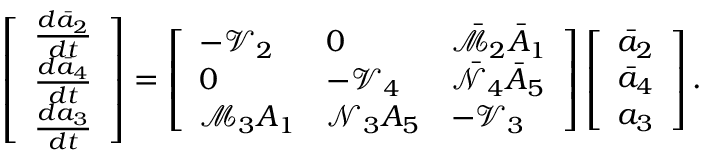Convert formula to latex. <formula><loc_0><loc_0><loc_500><loc_500>\left [ \begin{array} { l } { \frac { d \bar { a } _ { 2 } } { d t } } \\ { \frac { d \bar { a } _ { 4 } } { d t } } \\ { \frac { d { a } _ { 3 } } { d t } } \end{array} \right ] = \left [ \begin{array} { l l l } { - \mathcal { V } _ { 2 } } & { 0 } & { \bar { { \mathcal { M } } } _ { 2 } \bar { A } _ { 1 } } \\ { 0 } & { - \mathcal { V } _ { 4 } } & { \bar { \mathcal { N } } _ { 4 } \bar { A } _ { 5 } } \\ { { \mathcal { M } } _ { 3 } { A } _ { 1 } } & { { \mathcal { N } } _ { 3 } { A } _ { 5 } } & { - \mathcal { V } _ { 3 } } \end{array} \right ] \left [ \begin{array} { l } { \bar { a } _ { 2 } } \\ { \bar { a } _ { 4 } } \\ { { a } _ { 3 } } \end{array} \right ] .</formula> 